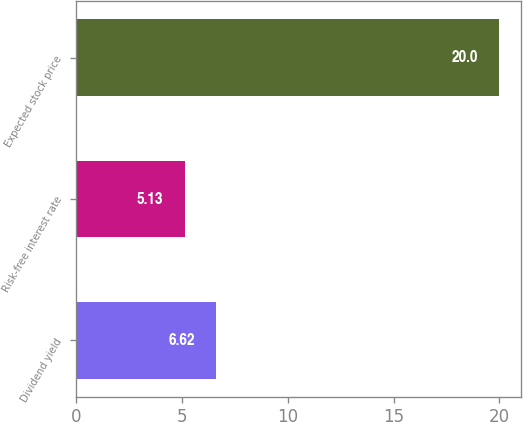<chart> <loc_0><loc_0><loc_500><loc_500><bar_chart><fcel>Dividend yield<fcel>Risk-free interest rate<fcel>Expected stock price<nl><fcel>6.62<fcel>5.13<fcel>20<nl></chart> 